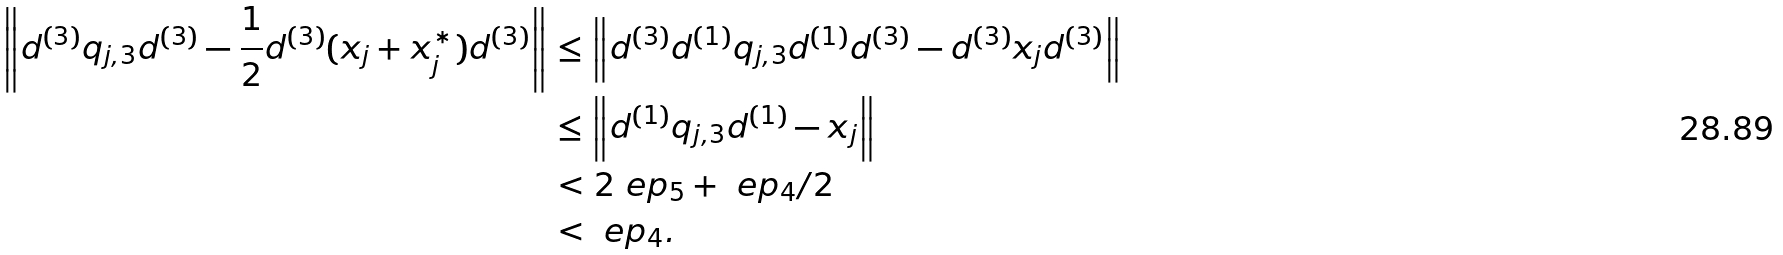<formula> <loc_0><loc_0><loc_500><loc_500>\left \| d ^ { ( 3 ) } q _ { j , 3 } d ^ { ( 3 ) } - \frac { 1 } { 2 } d ^ { ( 3 ) } ( x _ { j } + x _ { j } ^ { * } ) d ^ { ( 3 ) } \right \| & \leq \left \| d ^ { ( 3 ) } d ^ { ( 1 ) } q _ { j , 3 } d ^ { ( 1 ) } d ^ { ( 3 ) } - d ^ { ( 3 ) } x _ { j } d ^ { ( 3 ) } \right \| \\ & \leq \left \| d ^ { ( 1 ) } q _ { j , 3 } d ^ { ( 1 ) } - x _ { j } \right \| \\ & < 2 \ e p _ { 5 } + \ e p _ { 4 } / 2 \\ & < \ e p _ { 4 } .</formula> 